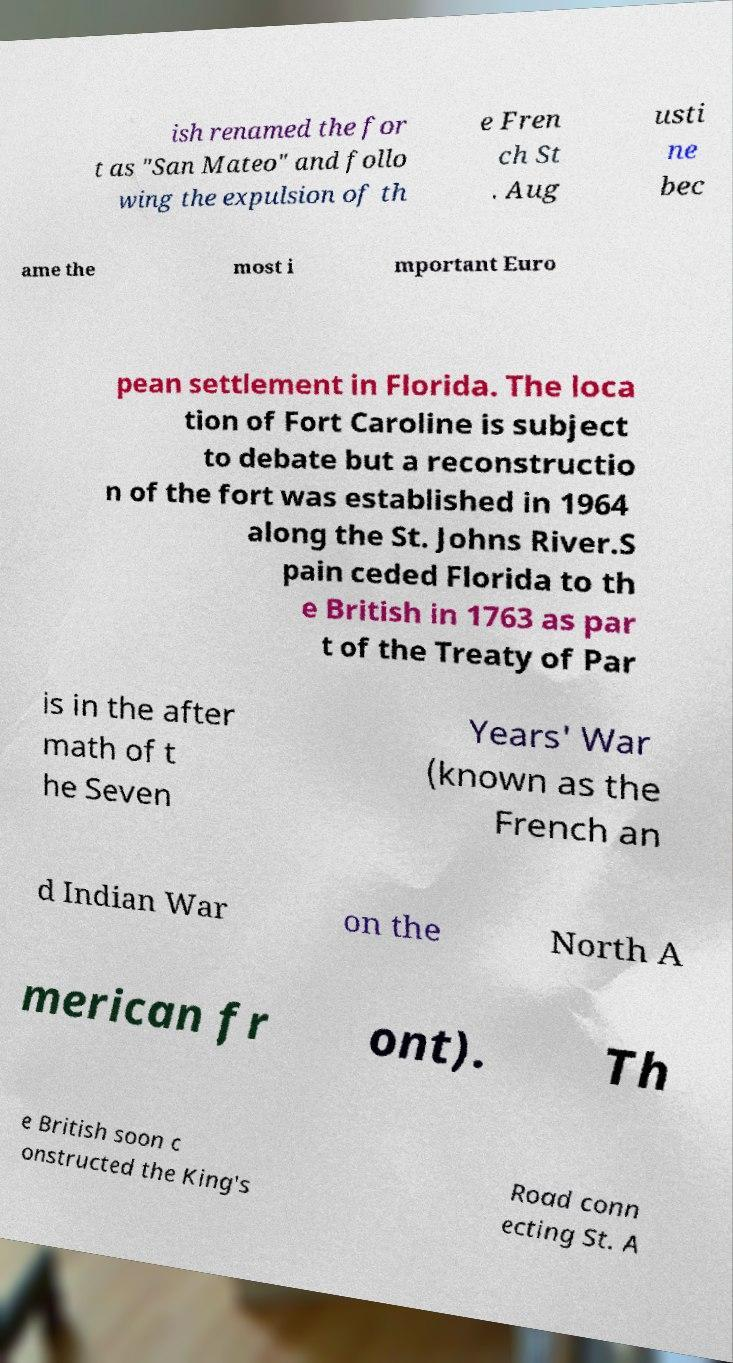For documentation purposes, I need the text within this image transcribed. Could you provide that? ish renamed the for t as "San Mateo" and follo wing the expulsion of th e Fren ch St . Aug usti ne bec ame the most i mportant Euro pean settlement in Florida. The loca tion of Fort Caroline is subject to debate but a reconstructio n of the fort was established in 1964 along the St. Johns River.S pain ceded Florida to th e British in 1763 as par t of the Treaty of Par is in the after math of t he Seven Years' War (known as the French an d Indian War on the North A merican fr ont). Th e British soon c onstructed the King's Road conn ecting St. A 